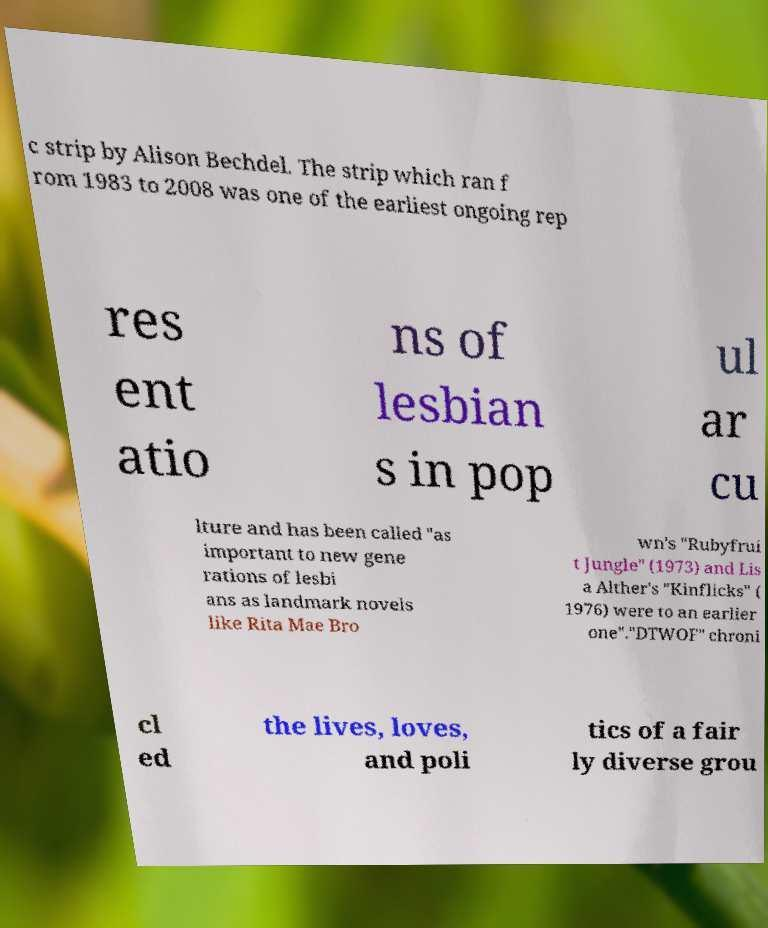Please identify and transcribe the text found in this image. c strip by Alison Bechdel. The strip which ran f rom 1983 to 2008 was one of the earliest ongoing rep res ent atio ns of lesbian s in pop ul ar cu lture and has been called "as important to new gene rations of lesbi ans as landmark novels like Rita Mae Bro wn's "Rubyfrui t Jungle" (1973) and Lis a Alther's "Kinflicks" ( 1976) were to an earlier one"."DTWOF" chroni cl ed the lives, loves, and poli tics of a fair ly diverse grou 